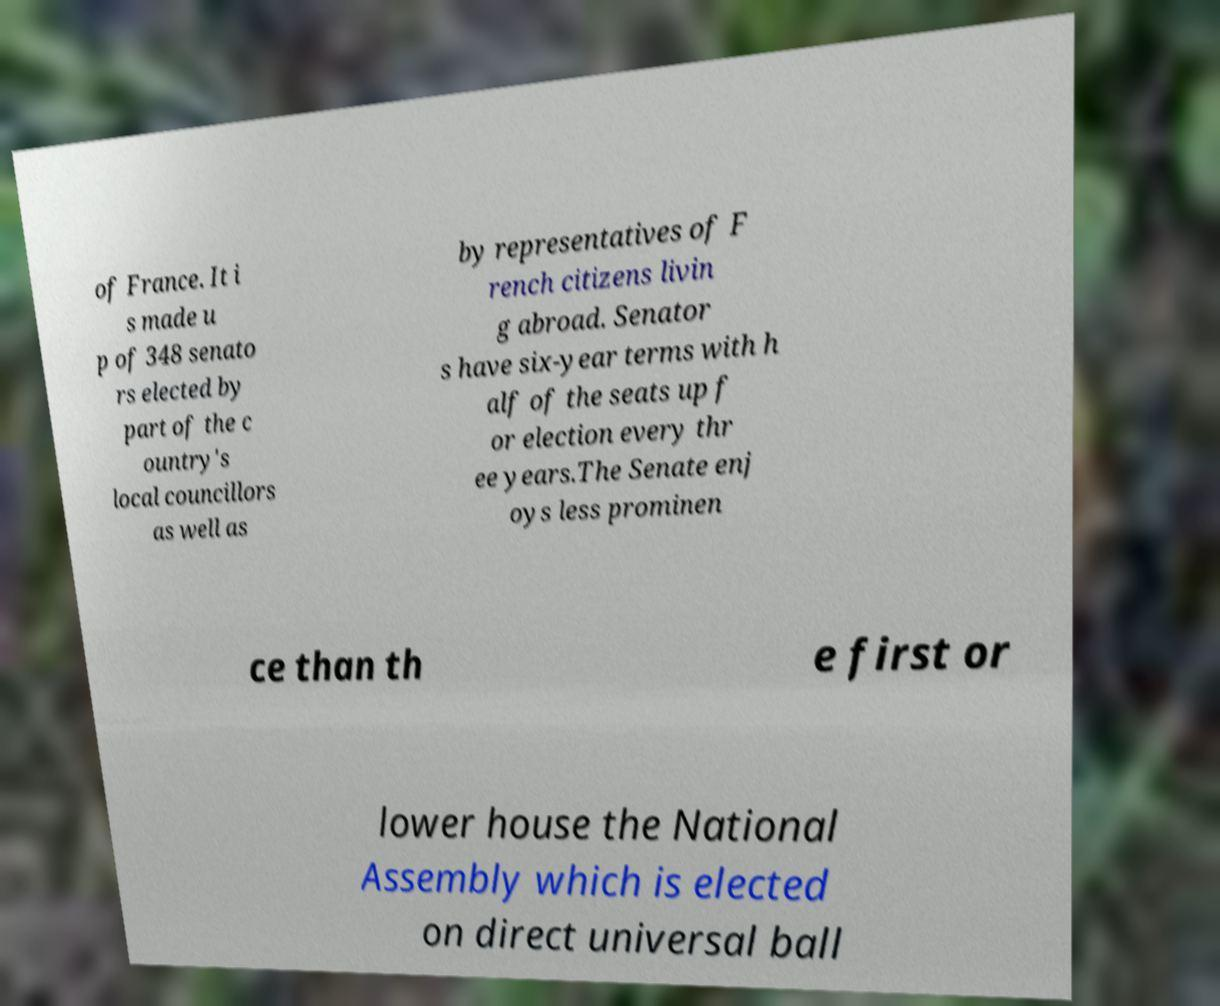Can you accurately transcribe the text from the provided image for me? of France. It i s made u p of 348 senato rs elected by part of the c ountry's local councillors as well as by representatives of F rench citizens livin g abroad. Senator s have six-year terms with h alf of the seats up f or election every thr ee years.The Senate enj oys less prominen ce than th e first or lower house the National Assembly which is elected on direct universal ball 